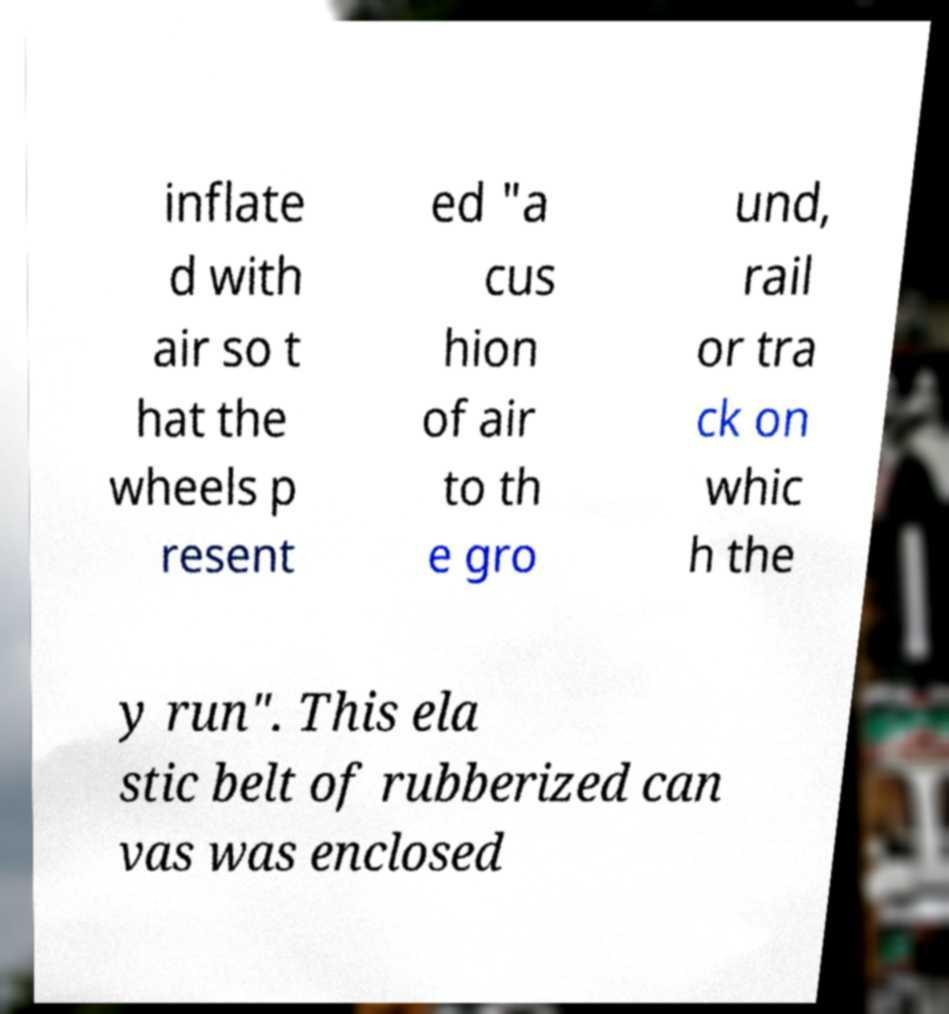Could you assist in decoding the text presented in this image and type it out clearly? inflate d with air so t hat the wheels p resent ed "a cus hion of air to th e gro und, rail or tra ck on whic h the y run". This ela stic belt of rubberized can vas was enclosed 